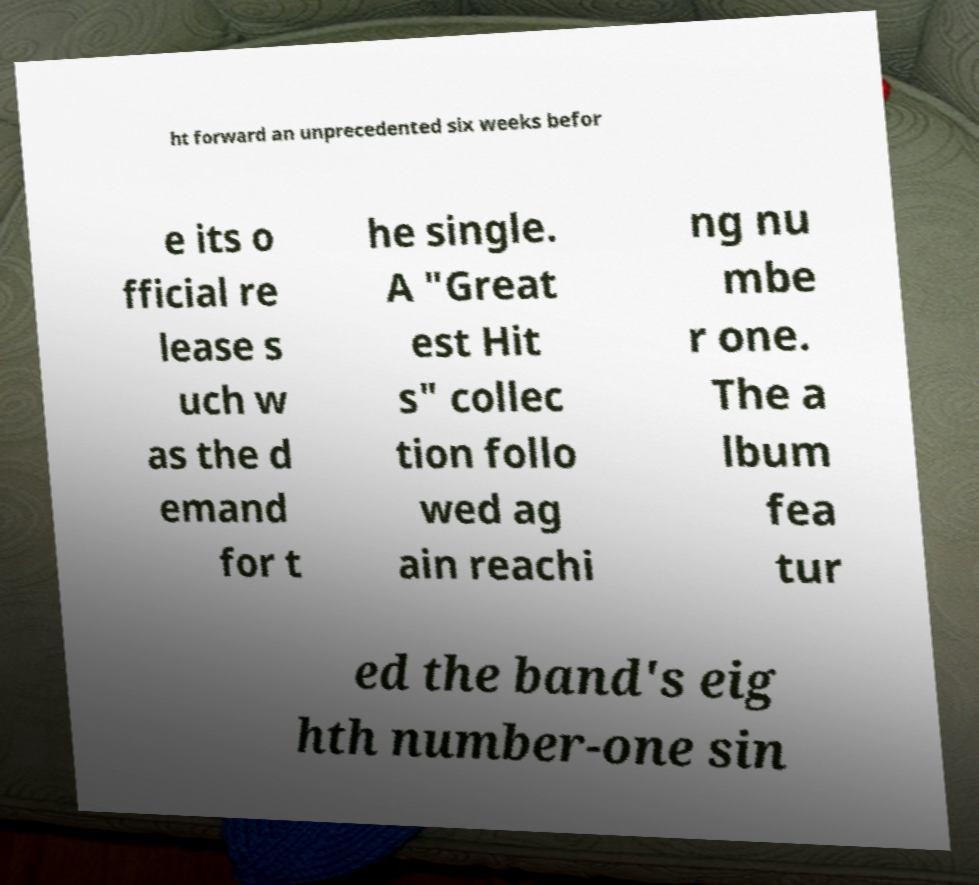Please identify and transcribe the text found in this image. ht forward an unprecedented six weeks befor e its o fficial re lease s uch w as the d emand for t he single. A "Great est Hit s" collec tion follo wed ag ain reachi ng nu mbe r one. The a lbum fea tur ed the band's eig hth number-one sin 